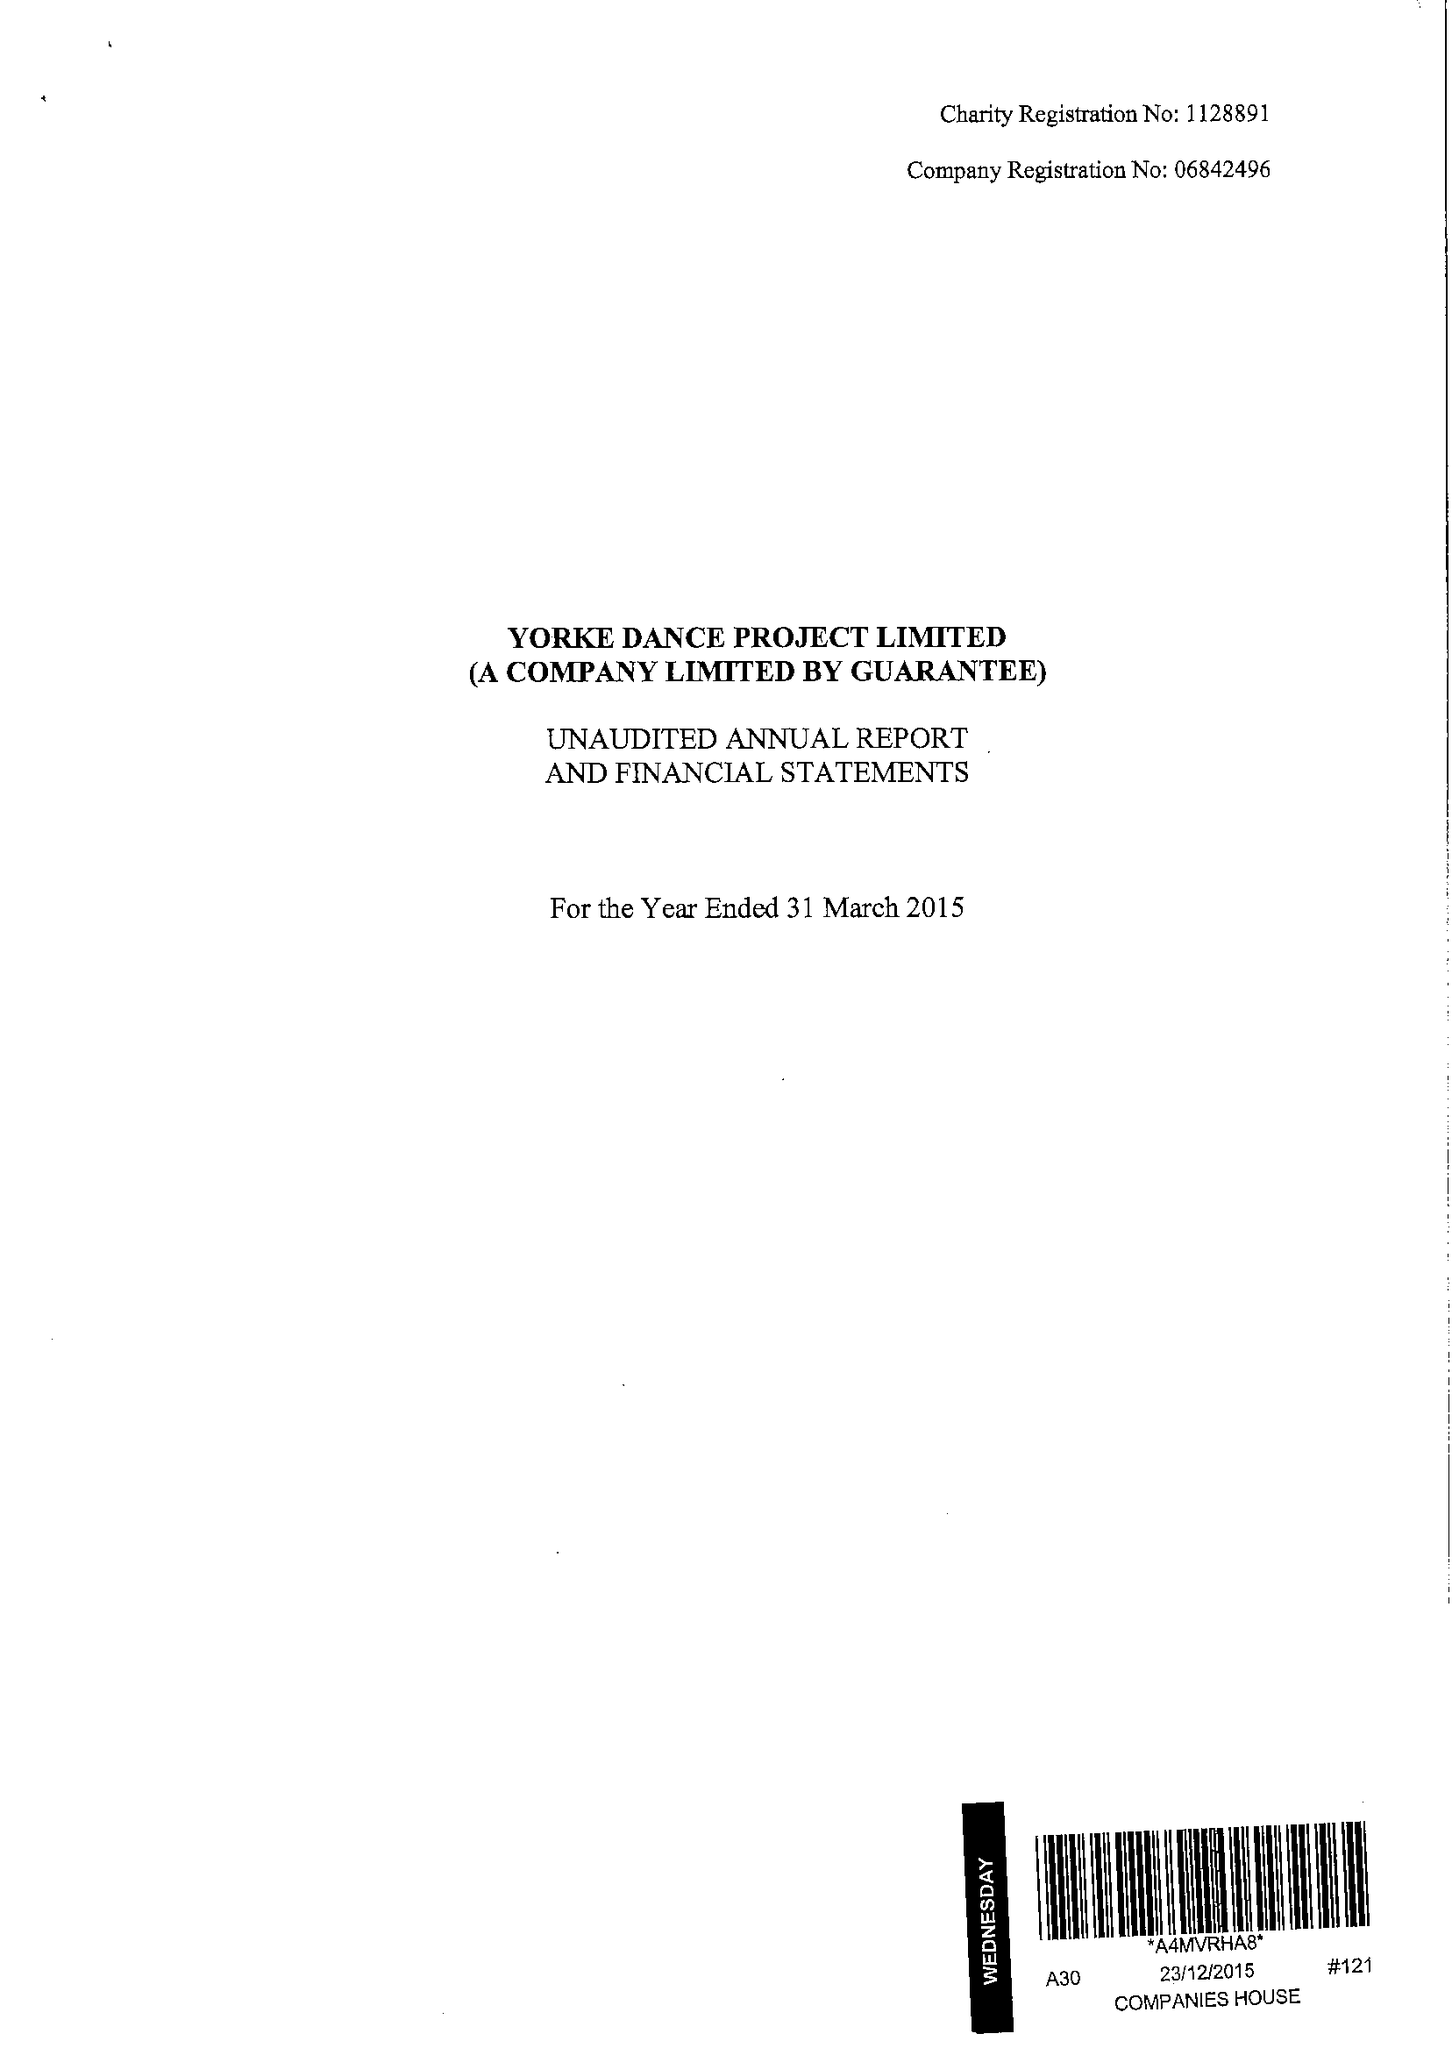What is the value for the charity_name?
Answer the question using a single word or phrase. Yorke Dance Project Ltd. 